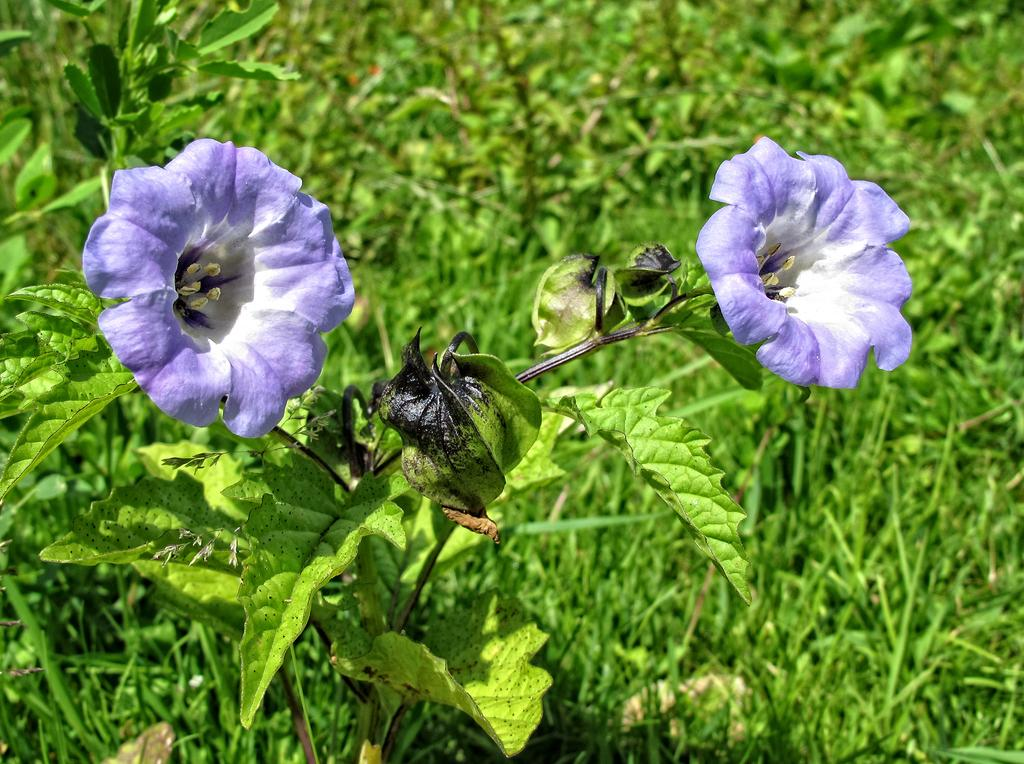What type of plants can be seen in the image? There are flowers in the image. What parts of the flowers are visible? The flowers have leaves and stems. What type of vegetation is visible in the image besides the flowers? There is grass visible in the image. What type of cakes are being sold at the store in the image? There is no store or cakes present in the image; it features flowers with leaves and stems, as well as grass. 